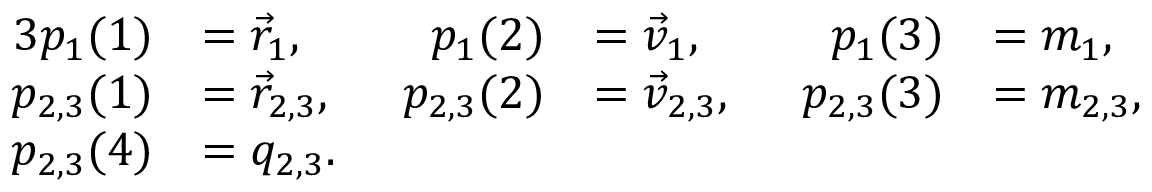<formula> <loc_0><loc_0><loc_500><loc_500>\begin{array} { r l r l r l } { { 3 } p _ { 1 } ( 1 ) } & { = \vec { r } _ { 1 } , } & { p _ { 1 } ( 2 ) } & { = \vec { v } _ { 1 } , } & { p _ { 1 } ( 3 ) } & { = m _ { 1 } , } \\ { p _ { 2 , 3 } ( 1 ) } & { = \vec { r } _ { 2 , 3 } , \, } & { p _ { 2 , 3 } ( 2 ) } & { = \vec { v } _ { 2 , 3 } , \, } & { p _ { 2 , 3 } ( 3 ) } & { = m _ { 2 , 3 } , } \\ { p _ { 2 , 3 } ( 4 ) } & { = q _ { 2 , 3 } . } \end{array}</formula> 